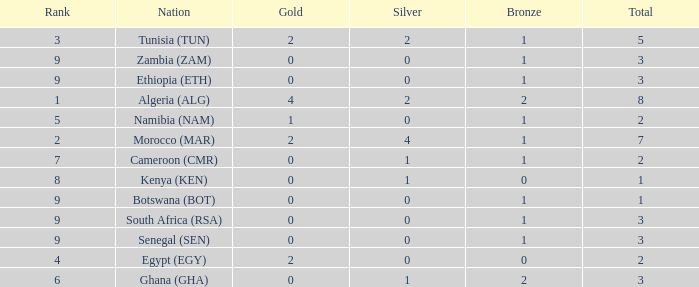What is the average Total with a Nation of ethiopia (eth) and a Rank that is larger than 9? None. 